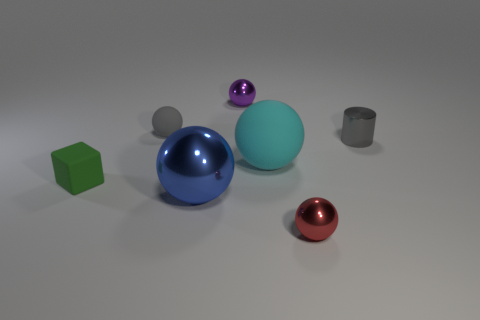Is there anything else that has the same shape as the small green matte object?
Provide a succinct answer. No. Are the large sphere that is on the right side of the purple metal sphere and the large sphere that is in front of the tiny green matte block made of the same material?
Ensure brevity in your answer.  No. There is a cyan matte object that is left of the tiny metallic object in front of the small green matte object in front of the gray metal object; what is its size?
Offer a very short reply. Large. How many spheres have the same material as the blue thing?
Provide a succinct answer. 2. Are there fewer cyan rubber objects than brown cubes?
Provide a short and direct response. No. What size is the purple shiny object that is the same shape as the gray matte object?
Provide a succinct answer. Small. Does the large sphere that is in front of the large cyan rubber ball have the same material as the red object?
Your answer should be compact. Yes. Is the cyan object the same shape as the red thing?
Give a very brief answer. Yes. What number of things are either small shiny spheres that are left of the tiny red object or purple balls?
Offer a very short reply. 1. The purple object that is the same material as the cylinder is what size?
Provide a short and direct response. Small. 